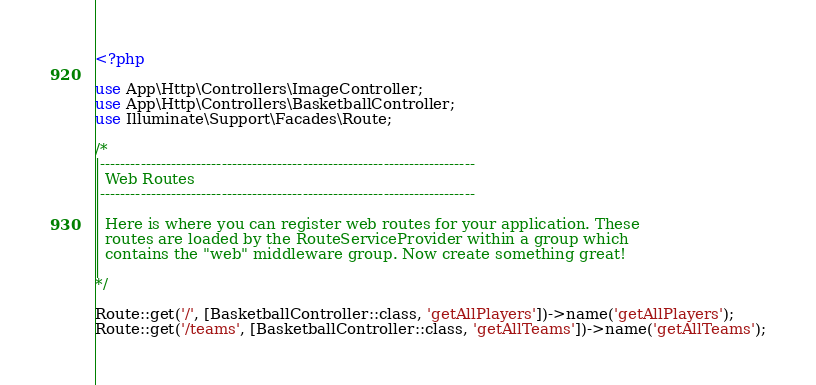Convert code to text. <code><loc_0><loc_0><loc_500><loc_500><_PHP_><?php

use App\Http\Controllers\ImageController;
use App\Http\Controllers\BasketballController;
use Illuminate\Support\Facades\Route;

/*
|--------------------------------------------------------------------------
| Web Routes
|--------------------------------------------------------------------------
|
| Here is where you can register web routes for your application. These
| routes are loaded by the RouteServiceProvider within a group which
| contains the "web" middleware group. Now create something great!
|
*/

Route::get('/', [BasketballController::class, 'getAllPlayers'])->name('getAllPlayers');
Route::get('/teams', [BasketballController::class, 'getAllTeams'])->name('getAllTeams');
</code> 